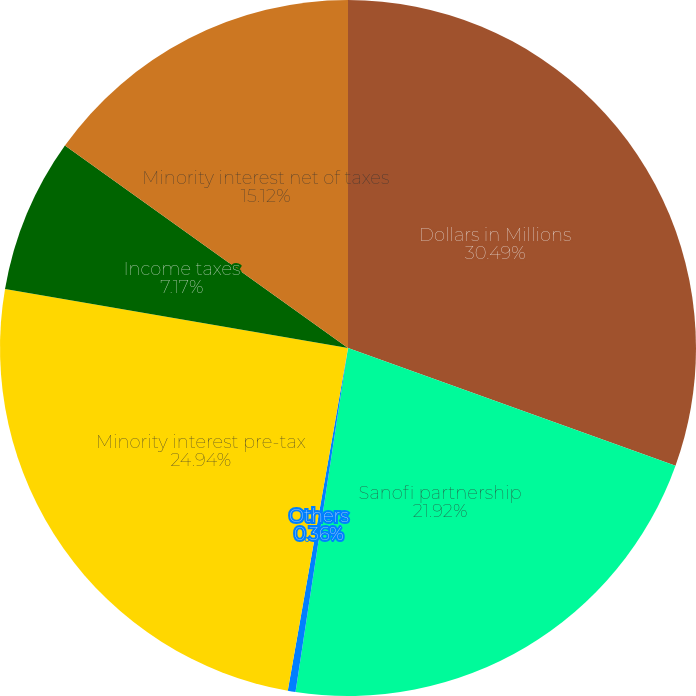Convert chart to OTSL. <chart><loc_0><loc_0><loc_500><loc_500><pie_chart><fcel>Dollars in Millions<fcel>Sanofi partnership<fcel>Others<fcel>Minority interest pre-tax<fcel>Income taxes<fcel>Minority interest net of taxes<nl><fcel>30.49%<fcel>21.92%<fcel>0.36%<fcel>24.94%<fcel>7.17%<fcel>15.12%<nl></chart> 